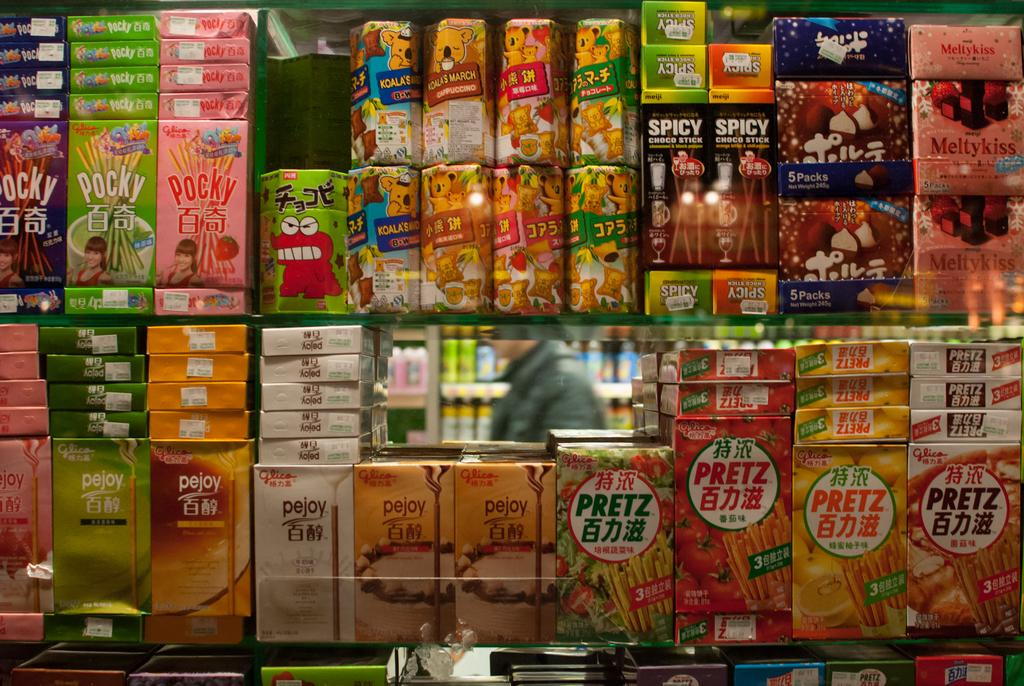Provide a one-sentence caption for the provided image. The bottom right corner of the shelve is where the Pretz crackers are held. 